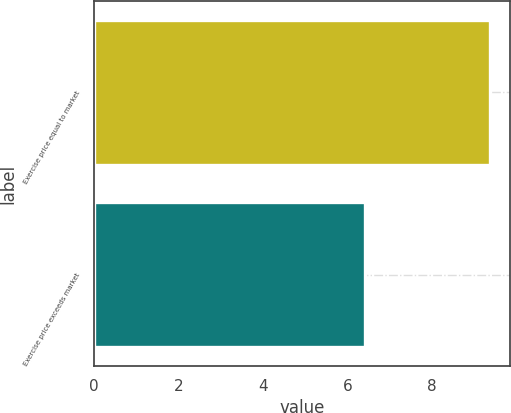Convert chart. <chart><loc_0><loc_0><loc_500><loc_500><bar_chart><fcel>Exercise price equal to market<fcel>Exercise price exceeds market<nl><fcel>9.38<fcel>6.42<nl></chart> 